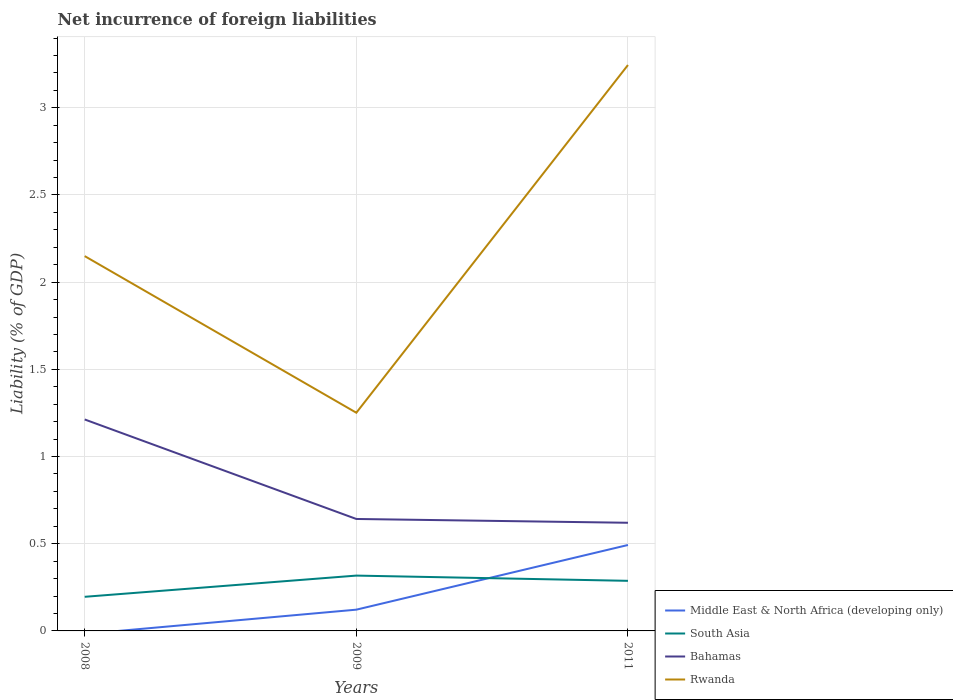Does the line corresponding to Middle East & North Africa (developing only) intersect with the line corresponding to Rwanda?
Make the answer very short. No. Across all years, what is the maximum net incurrence of foreign liabilities in South Asia?
Your answer should be very brief. 0.2. What is the total net incurrence of foreign liabilities in Rwanda in the graph?
Provide a short and direct response. 0.9. What is the difference between the highest and the second highest net incurrence of foreign liabilities in Rwanda?
Offer a very short reply. 1.99. What is the difference between the highest and the lowest net incurrence of foreign liabilities in Bahamas?
Offer a very short reply. 1. How many years are there in the graph?
Your answer should be very brief. 3. Are the values on the major ticks of Y-axis written in scientific E-notation?
Your answer should be very brief. No. Does the graph contain any zero values?
Provide a short and direct response. Yes. Where does the legend appear in the graph?
Your answer should be very brief. Bottom right. How many legend labels are there?
Keep it short and to the point. 4. What is the title of the graph?
Your answer should be compact. Net incurrence of foreign liabilities. Does "Europe(developing only)" appear as one of the legend labels in the graph?
Keep it short and to the point. No. What is the label or title of the Y-axis?
Your response must be concise. Liability (% of GDP). What is the Liability (% of GDP) in South Asia in 2008?
Offer a terse response. 0.2. What is the Liability (% of GDP) in Bahamas in 2008?
Your answer should be very brief. 1.21. What is the Liability (% of GDP) in Rwanda in 2008?
Keep it short and to the point. 2.15. What is the Liability (% of GDP) of Middle East & North Africa (developing only) in 2009?
Ensure brevity in your answer.  0.12. What is the Liability (% of GDP) of South Asia in 2009?
Give a very brief answer. 0.32. What is the Liability (% of GDP) of Bahamas in 2009?
Make the answer very short. 0.64. What is the Liability (% of GDP) of Rwanda in 2009?
Make the answer very short. 1.25. What is the Liability (% of GDP) in Middle East & North Africa (developing only) in 2011?
Your answer should be very brief. 0.49. What is the Liability (% of GDP) in South Asia in 2011?
Offer a very short reply. 0.29. What is the Liability (% of GDP) in Bahamas in 2011?
Your response must be concise. 0.62. What is the Liability (% of GDP) of Rwanda in 2011?
Offer a terse response. 3.25. Across all years, what is the maximum Liability (% of GDP) of Middle East & North Africa (developing only)?
Ensure brevity in your answer.  0.49. Across all years, what is the maximum Liability (% of GDP) in South Asia?
Ensure brevity in your answer.  0.32. Across all years, what is the maximum Liability (% of GDP) in Bahamas?
Your answer should be compact. 1.21. Across all years, what is the maximum Liability (% of GDP) in Rwanda?
Keep it short and to the point. 3.25. Across all years, what is the minimum Liability (% of GDP) of South Asia?
Keep it short and to the point. 0.2. Across all years, what is the minimum Liability (% of GDP) of Bahamas?
Make the answer very short. 0.62. Across all years, what is the minimum Liability (% of GDP) of Rwanda?
Your answer should be very brief. 1.25. What is the total Liability (% of GDP) of Middle East & North Africa (developing only) in the graph?
Provide a short and direct response. 0.61. What is the total Liability (% of GDP) in South Asia in the graph?
Keep it short and to the point. 0.8. What is the total Liability (% of GDP) in Bahamas in the graph?
Provide a succinct answer. 2.47. What is the total Liability (% of GDP) of Rwanda in the graph?
Your answer should be very brief. 6.65. What is the difference between the Liability (% of GDP) of South Asia in 2008 and that in 2009?
Provide a short and direct response. -0.12. What is the difference between the Liability (% of GDP) in Bahamas in 2008 and that in 2009?
Make the answer very short. 0.57. What is the difference between the Liability (% of GDP) of Rwanda in 2008 and that in 2009?
Your answer should be very brief. 0.9. What is the difference between the Liability (% of GDP) of South Asia in 2008 and that in 2011?
Make the answer very short. -0.09. What is the difference between the Liability (% of GDP) of Bahamas in 2008 and that in 2011?
Offer a very short reply. 0.59. What is the difference between the Liability (% of GDP) of Rwanda in 2008 and that in 2011?
Offer a terse response. -1.1. What is the difference between the Liability (% of GDP) in Middle East & North Africa (developing only) in 2009 and that in 2011?
Give a very brief answer. -0.37. What is the difference between the Liability (% of GDP) in Bahamas in 2009 and that in 2011?
Make the answer very short. 0.02. What is the difference between the Liability (% of GDP) of Rwanda in 2009 and that in 2011?
Make the answer very short. -1.99. What is the difference between the Liability (% of GDP) of South Asia in 2008 and the Liability (% of GDP) of Bahamas in 2009?
Offer a very short reply. -0.45. What is the difference between the Liability (% of GDP) of South Asia in 2008 and the Liability (% of GDP) of Rwanda in 2009?
Ensure brevity in your answer.  -1.06. What is the difference between the Liability (% of GDP) of Bahamas in 2008 and the Liability (% of GDP) of Rwanda in 2009?
Provide a succinct answer. -0.04. What is the difference between the Liability (% of GDP) in South Asia in 2008 and the Liability (% of GDP) in Bahamas in 2011?
Make the answer very short. -0.42. What is the difference between the Liability (% of GDP) in South Asia in 2008 and the Liability (% of GDP) in Rwanda in 2011?
Offer a terse response. -3.05. What is the difference between the Liability (% of GDP) in Bahamas in 2008 and the Liability (% of GDP) in Rwanda in 2011?
Your response must be concise. -2.03. What is the difference between the Liability (% of GDP) in Middle East & North Africa (developing only) in 2009 and the Liability (% of GDP) in South Asia in 2011?
Your answer should be compact. -0.17. What is the difference between the Liability (% of GDP) in Middle East & North Africa (developing only) in 2009 and the Liability (% of GDP) in Bahamas in 2011?
Your answer should be very brief. -0.5. What is the difference between the Liability (% of GDP) in Middle East & North Africa (developing only) in 2009 and the Liability (% of GDP) in Rwanda in 2011?
Your answer should be compact. -3.12. What is the difference between the Liability (% of GDP) of South Asia in 2009 and the Liability (% of GDP) of Bahamas in 2011?
Ensure brevity in your answer.  -0.3. What is the difference between the Liability (% of GDP) in South Asia in 2009 and the Liability (% of GDP) in Rwanda in 2011?
Make the answer very short. -2.93. What is the difference between the Liability (% of GDP) of Bahamas in 2009 and the Liability (% of GDP) of Rwanda in 2011?
Provide a succinct answer. -2.6. What is the average Liability (% of GDP) of Middle East & North Africa (developing only) per year?
Make the answer very short. 0.2. What is the average Liability (% of GDP) of South Asia per year?
Keep it short and to the point. 0.27. What is the average Liability (% of GDP) of Bahamas per year?
Provide a succinct answer. 0.82. What is the average Liability (% of GDP) of Rwanda per year?
Ensure brevity in your answer.  2.22. In the year 2008, what is the difference between the Liability (% of GDP) of South Asia and Liability (% of GDP) of Bahamas?
Make the answer very short. -1.02. In the year 2008, what is the difference between the Liability (% of GDP) of South Asia and Liability (% of GDP) of Rwanda?
Provide a succinct answer. -1.95. In the year 2008, what is the difference between the Liability (% of GDP) of Bahamas and Liability (% of GDP) of Rwanda?
Your answer should be compact. -0.94. In the year 2009, what is the difference between the Liability (% of GDP) in Middle East & North Africa (developing only) and Liability (% of GDP) in South Asia?
Give a very brief answer. -0.2. In the year 2009, what is the difference between the Liability (% of GDP) in Middle East & North Africa (developing only) and Liability (% of GDP) in Bahamas?
Give a very brief answer. -0.52. In the year 2009, what is the difference between the Liability (% of GDP) of Middle East & North Africa (developing only) and Liability (% of GDP) of Rwanda?
Your response must be concise. -1.13. In the year 2009, what is the difference between the Liability (% of GDP) of South Asia and Liability (% of GDP) of Bahamas?
Provide a succinct answer. -0.32. In the year 2009, what is the difference between the Liability (% of GDP) in South Asia and Liability (% of GDP) in Rwanda?
Ensure brevity in your answer.  -0.93. In the year 2009, what is the difference between the Liability (% of GDP) of Bahamas and Liability (% of GDP) of Rwanda?
Offer a very short reply. -0.61. In the year 2011, what is the difference between the Liability (% of GDP) in Middle East & North Africa (developing only) and Liability (% of GDP) in South Asia?
Your response must be concise. 0.21. In the year 2011, what is the difference between the Liability (% of GDP) of Middle East & North Africa (developing only) and Liability (% of GDP) of Bahamas?
Provide a short and direct response. -0.13. In the year 2011, what is the difference between the Liability (% of GDP) of Middle East & North Africa (developing only) and Liability (% of GDP) of Rwanda?
Your answer should be very brief. -2.75. In the year 2011, what is the difference between the Liability (% of GDP) in South Asia and Liability (% of GDP) in Bahamas?
Ensure brevity in your answer.  -0.33. In the year 2011, what is the difference between the Liability (% of GDP) in South Asia and Liability (% of GDP) in Rwanda?
Your answer should be compact. -2.96. In the year 2011, what is the difference between the Liability (% of GDP) in Bahamas and Liability (% of GDP) in Rwanda?
Your response must be concise. -2.63. What is the ratio of the Liability (% of GDP) of South Asia in 2008 to that in 2009?
Your answer should be compact. 0.62. What is the ratio of the Liability (% of GDP) in Bahamas in 2008 to that in 2009?
Keep it short and to the point. 1.89. What is the ratio of the Liability (% of GDP) in Rwanda in 2008 to that in 2009?
Keep it short and to the point. 1.72. What is the ratio of the Liability (% of GDP) of South Asia in 2008 to that in 2011?
Your answer should be very brief. 0.68. What is the ratio of the Liability (% of GDP) in Bahamas in 2008 to that in 2011?
Offer a terse response. 1.96. What is the ratio of the Liability (% of GDP) in Rwanda in 2008 to that in 2011?
Keep it short and to the point. 0.66. What is the ratio of the Liability (% of GDP) of Middle East & North Africa (developing only) in 2009 to that in 2011?
Your answer should be very brief. 0.25. What is the ratio of the Liability (% of GDP) of South Asia in 2009 to that in 2011?
Keep it short and to the point. 1.1. What is the ratio of the Liability (% of GDP) of Bahamas in 2009 to that in 2011?
Provide a succinct answer. 1.03. What is the ratio of the Liability (% of GDP) in Rwanda in 2009 to that in 2011?
Provide a short and direct response. 0.39. What is the difference between the highest and the second highest Liability (% of GDP) of Bahamas?
Ensure brevity in your answer.  0.57. What is the difference between the highest and the second highest Liability (% of GDP) of Rwanda?
Make the answer very short. 1.1. What is the difference between the highest and the lowest Liability (% of GDP) of Middle East & North Africa (developing only)?
Ensure brevity in your answer.  0.49. What is the difference between the highest and the lowest Liability (% of GDP) in South Asia?
Provide a succinct answer. 0.12. What is the difference between the highest and the lowest Liability (% of GDP) of Bahamas?
Offer a very short reply. 0.59. What is the difference between the highest and the lowest Liability (% of GDP) of Rwanda?
Your answer should be very brief. 1.99. 